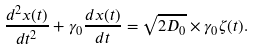Convert formula to latex. <formula><loc_0><loc_0><loc_500><loc_500>\frac { d ^ { 2 } x ( t ) } { d t ^ { 2 } } + \gamma _ { 0 } \frac { d x ( t ) } { d t } = \sqrt { 2 D _ { 0 } } \times \gamma _ { 0 } \zeta ( t ) .</formula> 